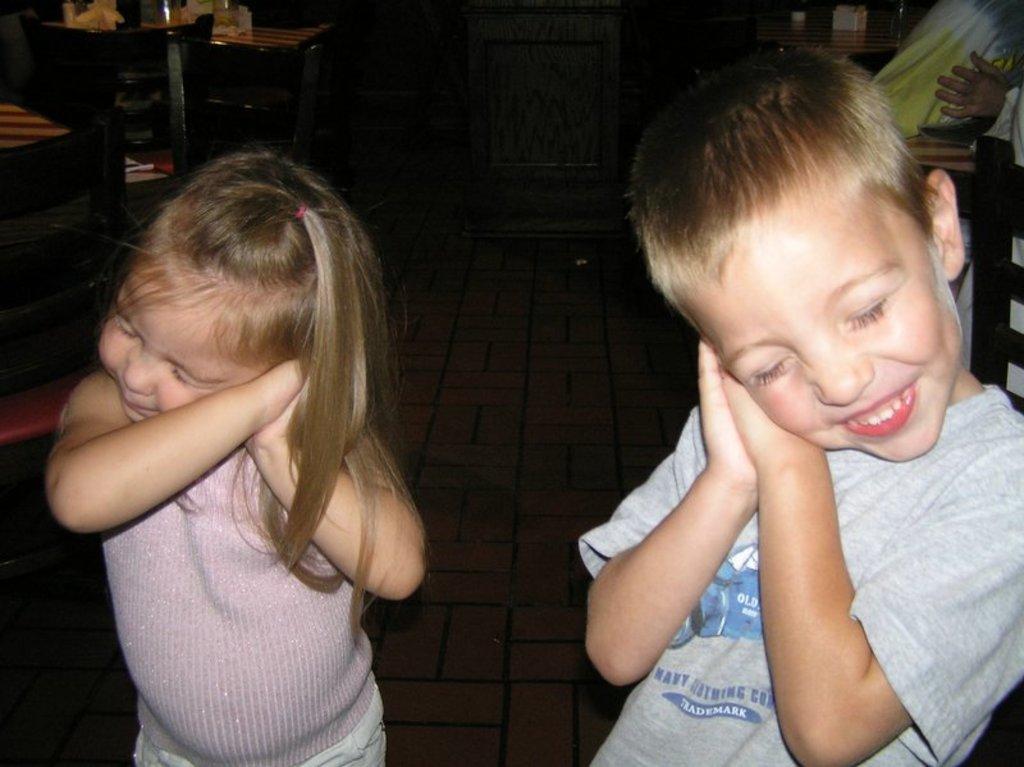Can you describe this image briefly? This is the picture of two kids who are standing and behind there are some table and some chairs. 